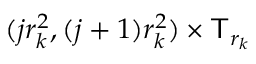Convert formula to latex. <formula><loc_0><loc_0><loc_500><loc_500>( j r _ { k } ^ { 2 } , ( j + 1 ) r _ { k } ^ { 2 } ) \times \mathsf T _ { r _ { k } }</formula> 